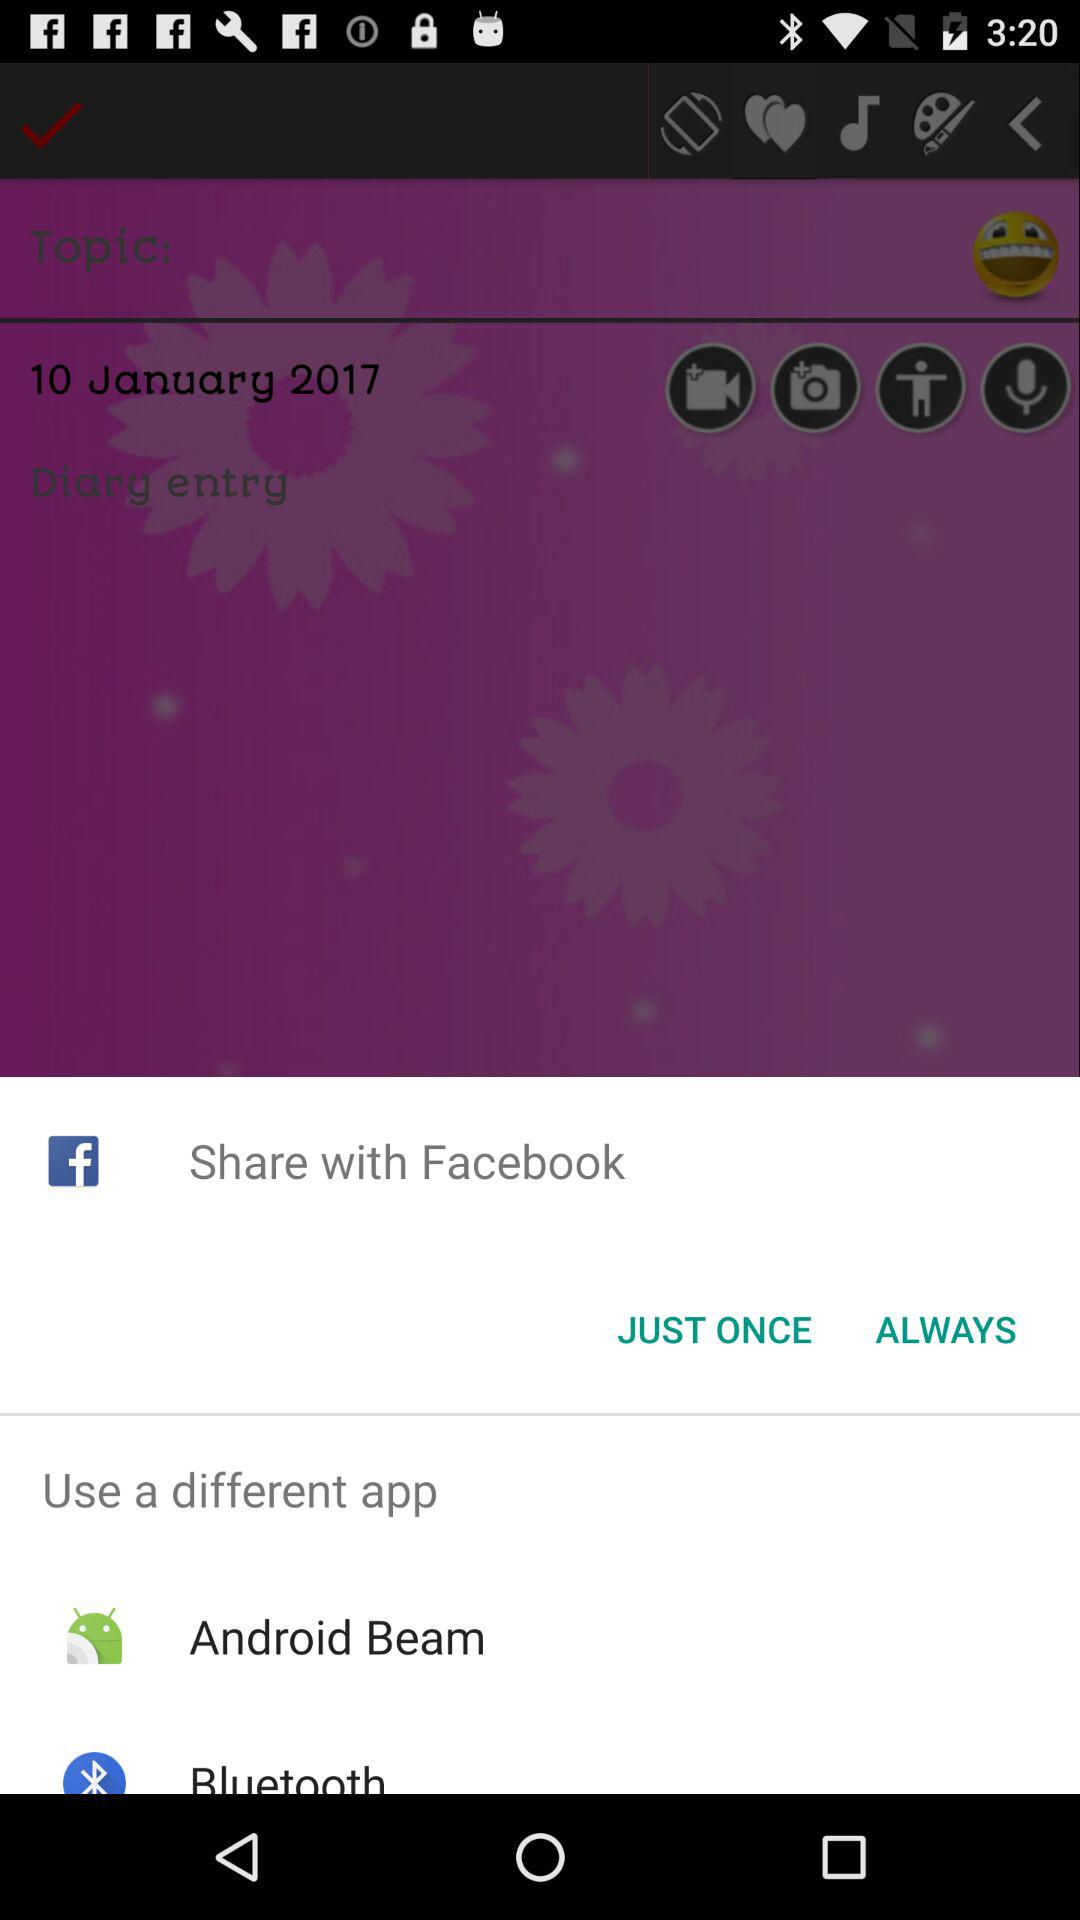What different applications can be used? The different application are "Android Beam" and "Bluetooth". 